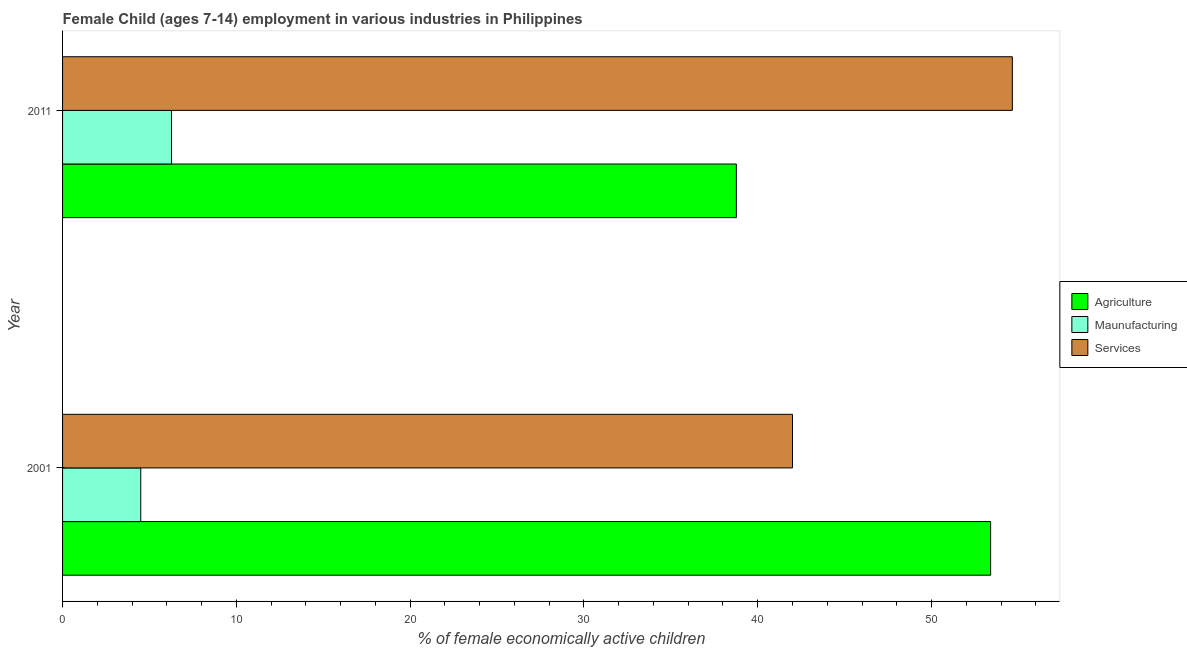How many different coloured bars are there?
Your response must be concise. 3. Are the number of bars per tick equal to the number of legend labels?
Give a very brief answer. Yes. Are the number of bars on each tick of the Y-axis equal?
Your answer should be very brief. Yes. How many bars are there on the 1st tick from the bottom?
Offer a terse response. 3. In how many cases, is the number of bars for a given year not equal to the number of legend labels?
Offer a very short reply. 0. What is the percentage of economically active children in manufacturing in 2011?
Offer a terse response. 6.27. Across all years, what is the maximum percentage of economically active children in agriculture?
Ensure brevity in your answer.  53.4. Across all years, what is the minimum percentage of economically active children in manufacturing?
Your answer should be compact. 4.5. In which year was the percentage of economically active children in services maximum?
Provide a succinct answer. 2011. What is the total percentage of economically active children in services in the graph?
Your answer should be compact. 96.65. What is the difference between the percentage of economically active children in services in 2001 and that in 2011?
Your response must be concise. -12.65. What is the difference between the percentage of economically active children in manufacturing in 2001 and the percentage of economically active children in services in 2011?
Keep it short and to the point. -50.15. What is the average percentage of economically active children in manufacturing per year?
Give a very brief answer. 5.38. What is the ratio of the percentage of economically active children in agriculture in 2001 to that in 2011?
Offer a very short reply. 1.38. Is the percentage of economically active children in manufacturing in 2001 less than that in 2011?
Make the answer very short. Yes. Is the difference between the percentage of economically active children in manufacturing in 2001 and 2011 greater than the difference between the percentage of economically active children in services in 2001 and 2011?
Provide a short and direct response. Yes. In how many years, is the percentage of economically active children in services greater than the average percentage of economically active children in services taken over all years?
Your answer should be compact. 1. What does the 1st bar from the top in 2011 represents?
Provide a succinct answer. Services. What does the 2nd bar from the bottom in 2001 represents?
Offer a very short reply. Maunufacturing. Is it the case that in every year, the sum of the percentage of economically active children in agriculture and percentage of economically active children in manufacturing is greater than the percentage of economically active children in services?
Offer a terse response. No. Are all the bars in the graph horizontal?
Keep it short and to the point. Yes. Where does the legend appear in the graph?
Ensure brevity in your answer.  Center right. How many legend labels are there?
Give a very brief answer. 3. How are the legend labels stacked?
Your answer should be very brief. Vertical. What is the title of the graph?
Your answer should be compact. Female Child (ages 7-14) employment in various industries in Philippines. What is the label or title of the X-axis?
Provide a short and direct response. % of female economically active children. What is the % of female economically active children of Agriculture in 2001?
Keep it short and to the point. 53.4. What is the % of female economically active children in Agriculture in 2011?
Ensure brevity in your answer.  38.77. What is the % of female economically active children in Maunufacturing in 2011?
Provide a short and direct response. 6.27. What is the % of female economically active children of Services in 2011?
Make the answer very short. 54.65. Across all years, what is the maximum % of female economically active children in Agriculture?
Keep it short and to the point. 53.4. Across all years, what is the maximum % of female economically active children in Maunufacturing?
Make the answer very short. 6.27. Across all years, what is the maximum % of female economically active children in Services?
Make the answer very short. 54.65. Across all years, what is the minimum % of female economically active children of Agriculture?
Make the answer very short. 38.77. Across all years, what is the minimum % of female economically active children of Maunufacturing?
Provide a short and direct response. 4.5. Across all years, what is the minimum % of female economically active children in Services?
Provide a short and direct response. 42. What is the total % of female economically active children of Agriculture in the graph?
Make the answer very short. 92.17. What is the total % of female economically active children of Maunufacturing in the graph?
Make the answer very short. 10.77. What is the total % of female economically active children of Services in the graph?
Keep it short and to the point. 96.65. What is the difference between the % of female economically active children in Agriculture in 2001 and that in 2011?
Keep it short and to the point. 14.63. What is the difference between the % of female economically active children in Maunufacturing in 2001 and that in 2011?
Offer a very short reply. -1.77. What is the difference between the % of female economically active children in Services in 2001 and that in 2011?
Ensure brevity in your answer.  -12.65. What is the difference between the % of female economically active children of Agriculture in 2001 and the % of female economically active children of Maunufacturing in 2011?
Your answer should be very brief. 47.13. What is the difference between the % of female economically active children of Agriculture in 2001 and the % of female economically active children of Services in 2011?
Provide a succinct answer. -1.25. What is the difference between the % of female economically active children of Maunufacturing in 2001 and the % of female economically active children of Services in 2011?
Make the answer very short. -50.15. What is the average % of female economically active children of Agriculture per year?
Offer a very short reply. 46.09. What is the average % of female economically active children in Maunufacturing per year?
Give a very brief answer. 5.38. What is the average % of female economically active children in Services per year?
Give a very brief answer. 48.33. In the year 2001, what is the difference between the % of female economically active children in Agriculture and % of female economically active children in Maunufacturing?
Make the answer very short. 48.9. In the year 2001, what is the difference between the % of female economically active children of Agriculture and % of female economically active children of Services?
Provide a short and direct response. 11.4. In the year 2001, what is the difference between the % of female economically active children in Maunufacturing and % of female economically active children in Services?
Your response must be concise. -37.5. In the year 2011, what is the difference between the % of female economically active children of Agriculture and % of female economically active children of Maunufacturing?
Provide a succinct answer. 32.5. In the year 2011, what is the difference between the % of female economically active children of Agriculture and % of female economically active children of Services?
Your answer should be very brief. -15.88. In the year 2011, what is the difference between the % of female economically active children in Maunufacturing and % of female economically active children in Services?
Your answer should be compact. -48.38. What is the ratio of the % of female economically active children in Agriculture in 2001 to that in 2011?
Make the answer very short. 1.38. What is the ratio of the % of female economically active children of Maunufacturing in 2001 to that in 2011?
Provide a succinct answer. 0.72. What is the ratio of the % of female economically active children in Services in 2001 to that in 2011?
Your answer should be compact. 0.77. What is the difference between the highest and the second highest % of female economically active children in Agriculture?
Your answer should be very brief. 14.63. What is the difference between the highest and the second highest % of female economically active children in Maunufacturing?
Your answer should be very brief. 1.77. What is the difference between the highest and the second highest % of female economically active children of Services?
Give a very brief answer. 12.65. What is the difference between the highest and the lowest % of female economically active children of Agriculture?
Offer a very short reply. 14.63. What is the difference between the highest and the lowest % of female economically active children in Maunufacturing?
Your response must be concise. 1.77. What is the difference between the highest and the lowest % of female economically active children of Services?
Keep it short and to the point. 12.65. 